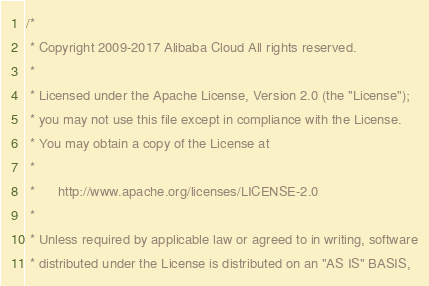<code> <loc_0><loc_0><loc_500><loc_500><_C++_>/*
 * Copyright 2009-2017 Alibaba Cloud All rights reserved.
 * 
 * Licensed under the Apache License, Version 2.0 (the "License");
 * you may not use this file except in compliance with the License.
 * You may obtain a copy of the License at
 * 
 *      http://www.apache.org/licenses/LICENSE-2.0
 * 
 * Unless required by applicable law or agreed to in writing, software
 * distributed under the License is distributed on an "AS IS" BASIS,</code> 